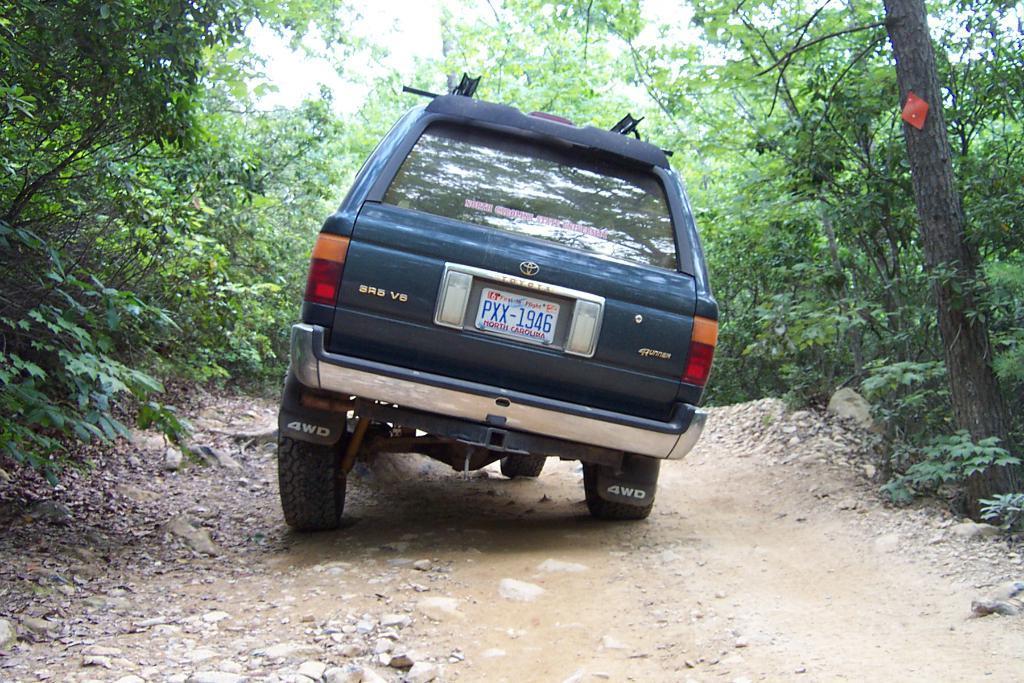Can you describe this image briefly? In this image there is a road, on the road there is a vehicle, beside the road there are some trees visible. 